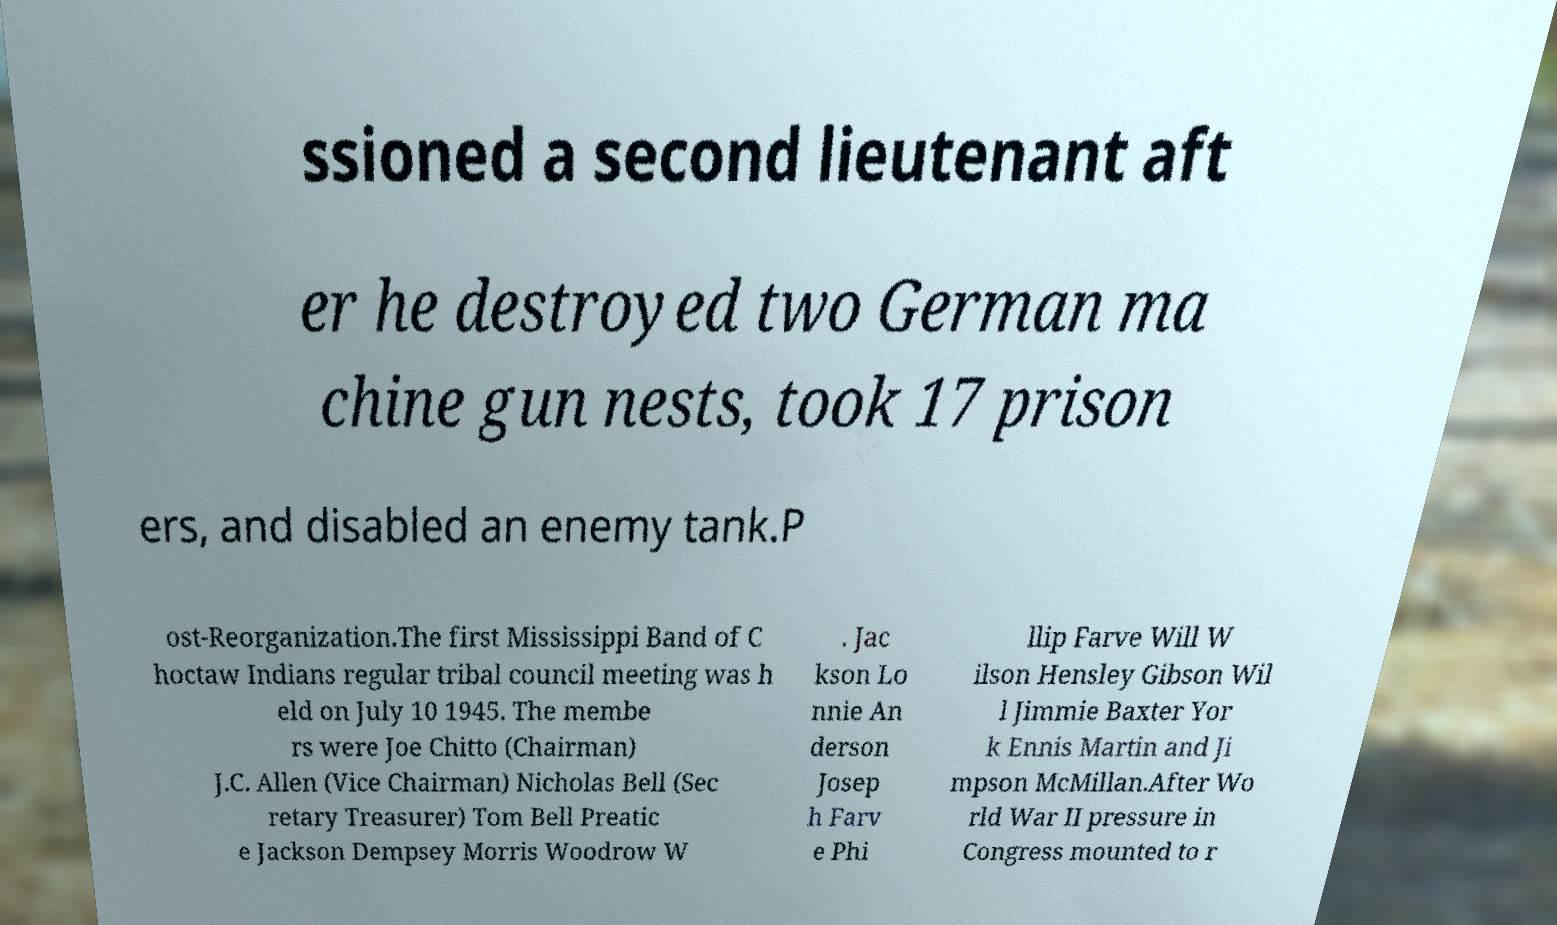There's text embedded in this image that I need extracted. Can you transcribe it verbatim? ssioned a second lieutenant aft er he destroyed two German ma chine gun nests, took 17 prison ers, and disabled an enemy tank.P ost-Reorganization.The first Mississippi Band of C hoctaw Indians regular tribal council meeting was h eld on July 10 1945. The membe rs were Joe Chitto (Chairman) J.C. Allen (Vice Chairman) Nicholas Bell (Sec retary Treasurer) Tom Bell Preatic e Jackson Dempsey Morris Woodrow W . Jac kson Lo nnie An derson Josep h Farv e Phi llip Farve Will W ilson Hensley Gibson Wil l Jimmie Baxter Yor k Ennis Martin and Ji mpson McMillan.After Wo rld War II pressure in Congress mounted to r 